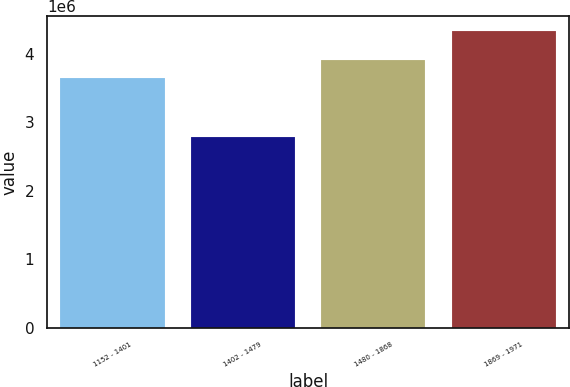Convert chart to OTSL. <chart><loc_0><loc_0><loc_500><loc_500><bar_chart><fcel>1152 - 1401<fcel>1402 - 1479<fcel>1480 - 1868<fcel>1869 - 1971<nl><fcel>3.65078e+06<fcel>2.78231e+06<fcel>3.91304e+06<fcel>4.33094e+06<nl></chart> 